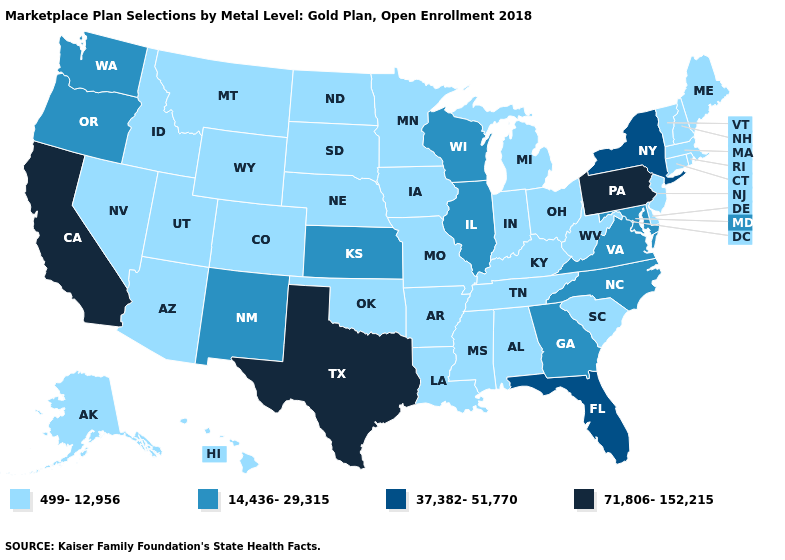What is the value of Alabama?
Write a very short answer. 499-12,956. Does the first symbol in the legend represent the smallest category?
Concise answer only. Yes. What is the highest value in the Northeast ?
Be succinct. 71,806-152,215. What is the value of Kansas?
Keep it brief. 14,436-29,315. Name the states that have a value in the range 37,382-51,770?
Concise answer only. Florida, New York. Among the states that border Missouri , which have the highest value?
Write a very short answer. Illinois, Kansas. Does Oklahoma have the same value as Rhode Island?
Give a very brief answer. Yes. Name the states that have a value in the range 37,382-51,770?
Answer briefly. Florida, New York. What is the lowest value in the USA?
Answer briefly. 499-12,956. Which states hav the highest value in the Northeast?
Keep it brief. Pennsylvania. What is the value of New York?
Short answer required. 37,382-51,770. What is the lowest value in the USA?
Short answer required. 499-12,956. 